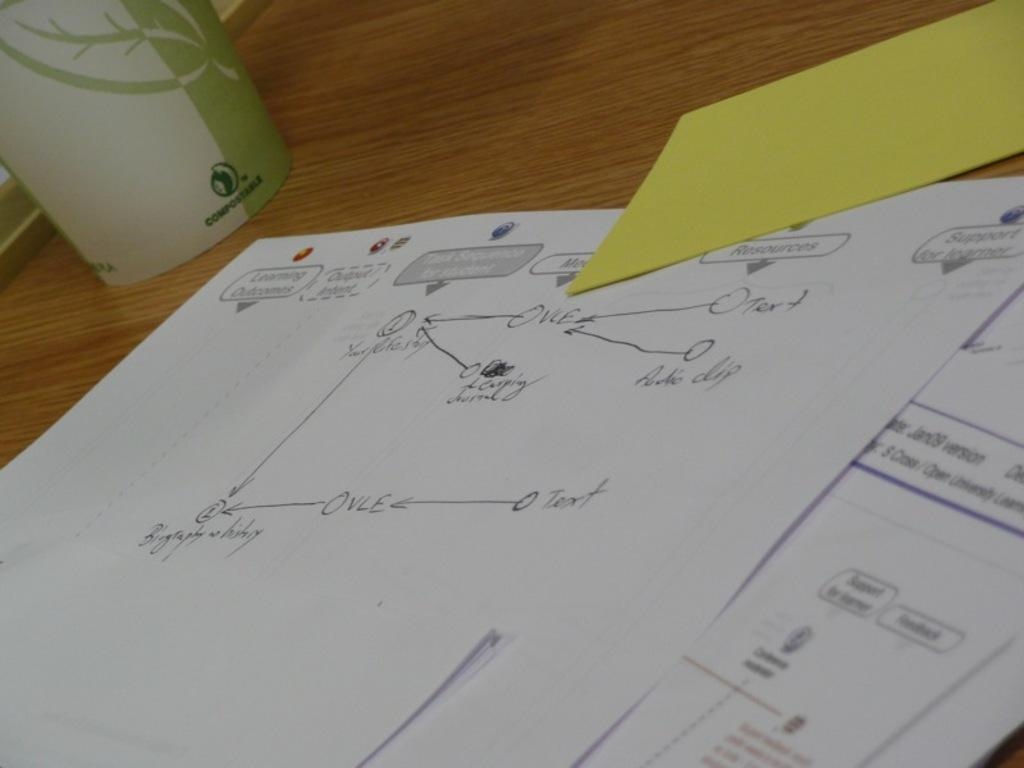<image>
Offer a succinct explanation of the picture presented. A handwritten diagram has labels for text and audio clip. 